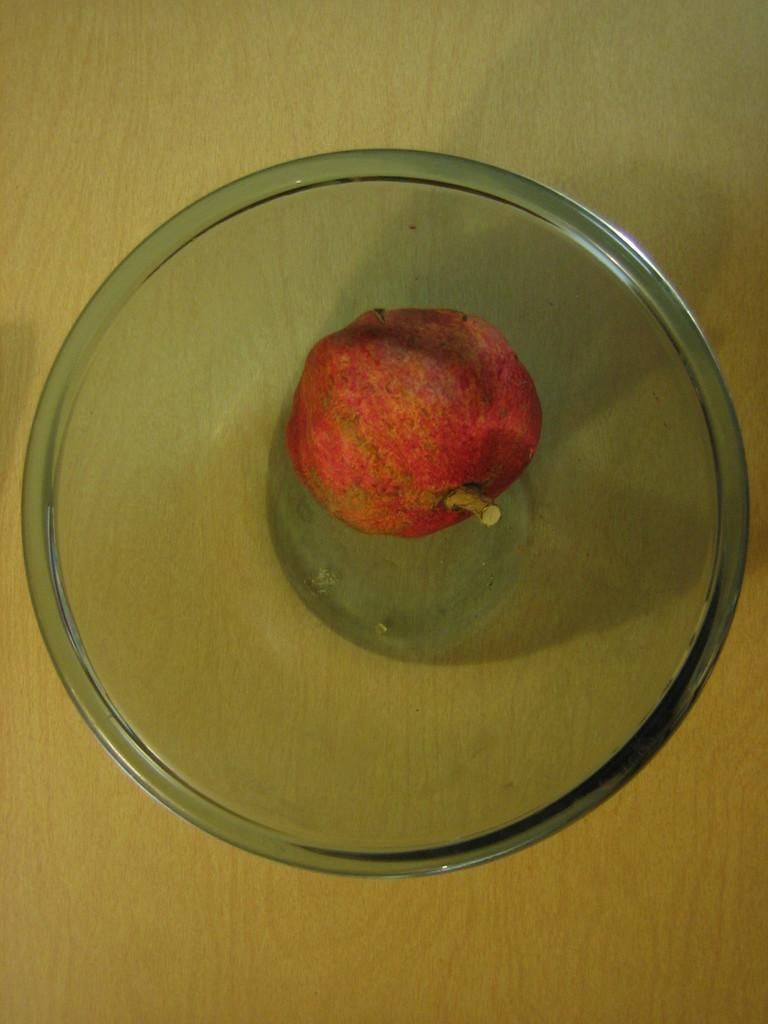What is in the bowl that is visible in the image? The bowl contains a fruit. Where is the bowl located in the image? The bowl is placed on a wooden plank. What type of pump can be seen in the image? There is no pump present in the image. What is located at the front of the image? The image does not have a specific front or orientation, so it's not possible to determine what might be located there. 